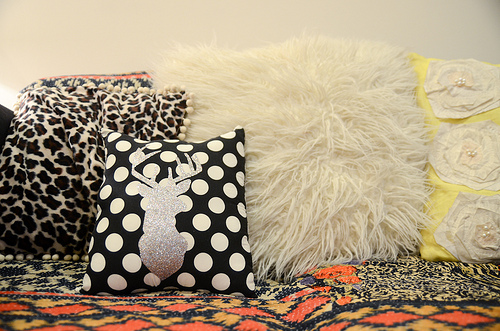<image>
Is there a deer pillow behind the rose pillow? No. The deer pillow is not behind the rose pillow. From this viewpoint, the deer pillow appears to be positioned elsewhere in the scene. 